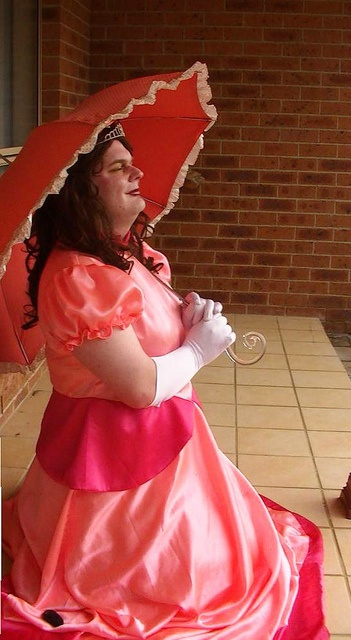Describe the objects in this image and their specific colors. I can see people in black, salmon, brown, and lightpink tones and umbrella in black, brown, maroon, and salmon tones in this image. 